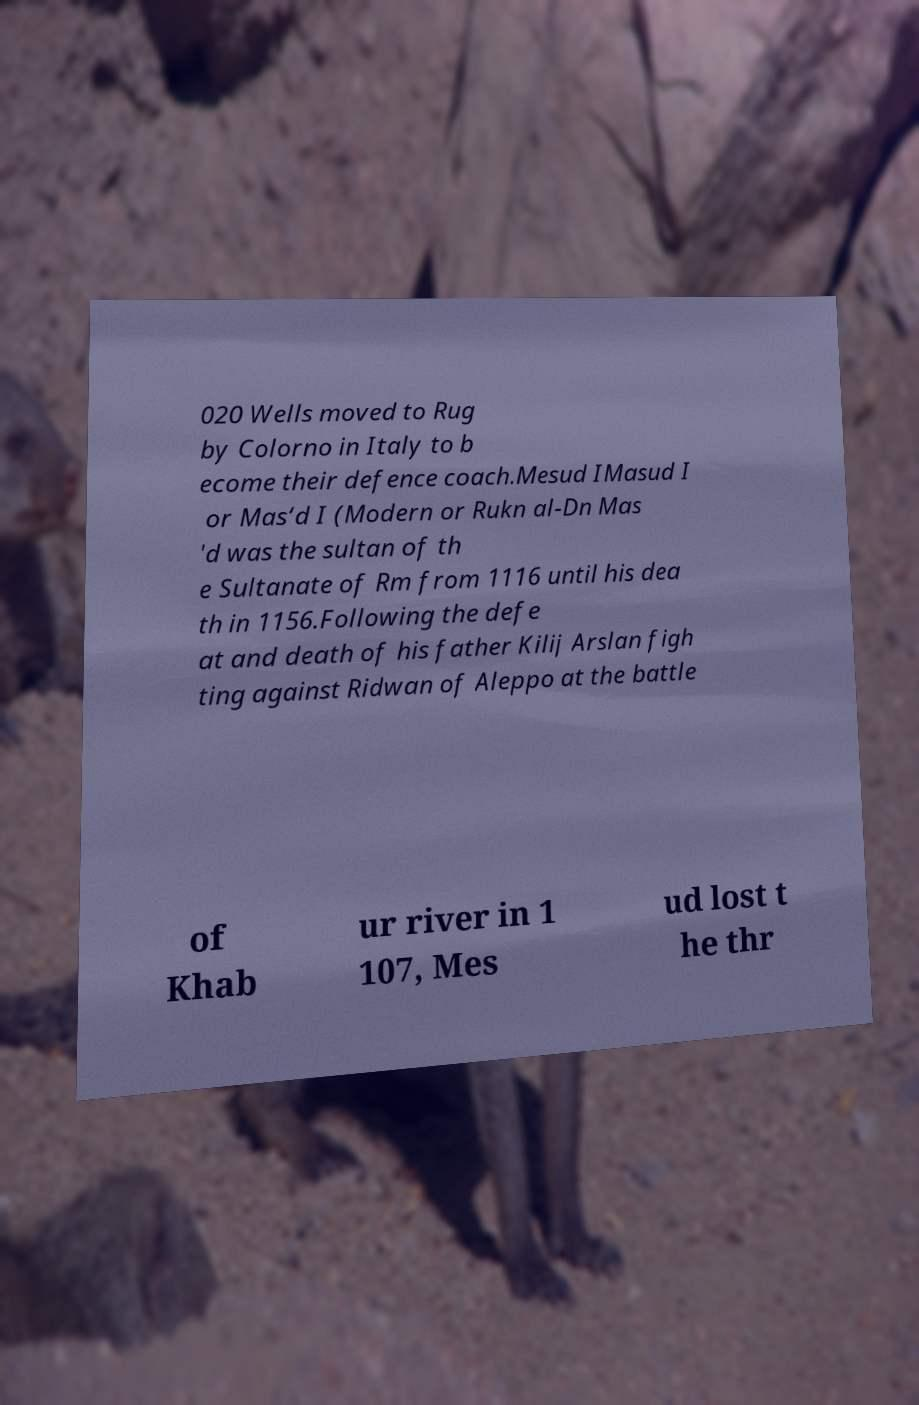Can you accurately transcribe the text from the provided image for me? 020 Wells moved to Rug by Colorno in Italy to b ecome their defence coach.Mesud IMasud I or Mas‘d I (Modern or Rukn al-Dn Mas 'd was the sultan of th e Sultanate of Rm from 1116 until his dea th in 1156.Following the defe at and death of his father Kilij Arslan figh ting against Ridwan of Aleppo at the battle of Khab ur river in 1 107, Mes ud lost t he thr 